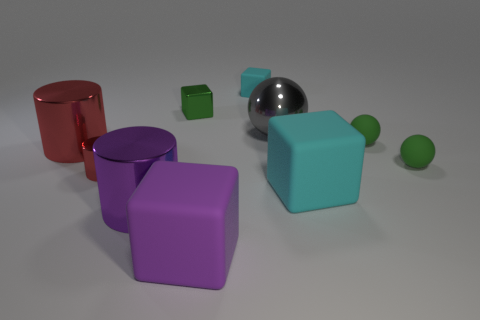Subtract all cubes. How many objects are left? 6 Subtract 1 purple cylinders. How many objects are left? 9 Subtract all green cubes. Subtract all cyan cubes. How many objects are left? 7 Add 1 large rubber objects. How many large rubber objects are left? 3 Add 8 tiny green shiny things. How many tiny green shiny things exist? 9 